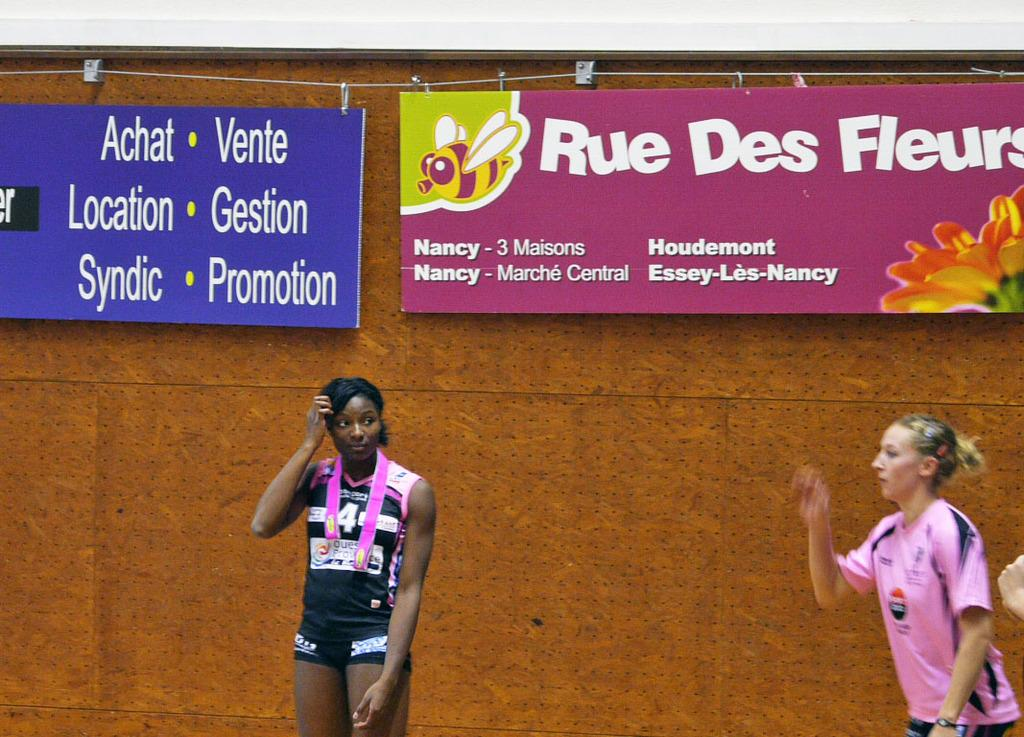How many women are present in the image? There are three women standing in the image. Can you describe the background of the image? There is a wall visible in the background of the image, along with banners and some objects. What might the banners be used for in the image? The banners in the background could be used for decoration or to convey a message. What type of bone can be seen in the hands of the women in the image? There are no bones visible in the hands of the women in the image. Can you describe the wings of the women in the image? There are no wings visible on the women in the image. 